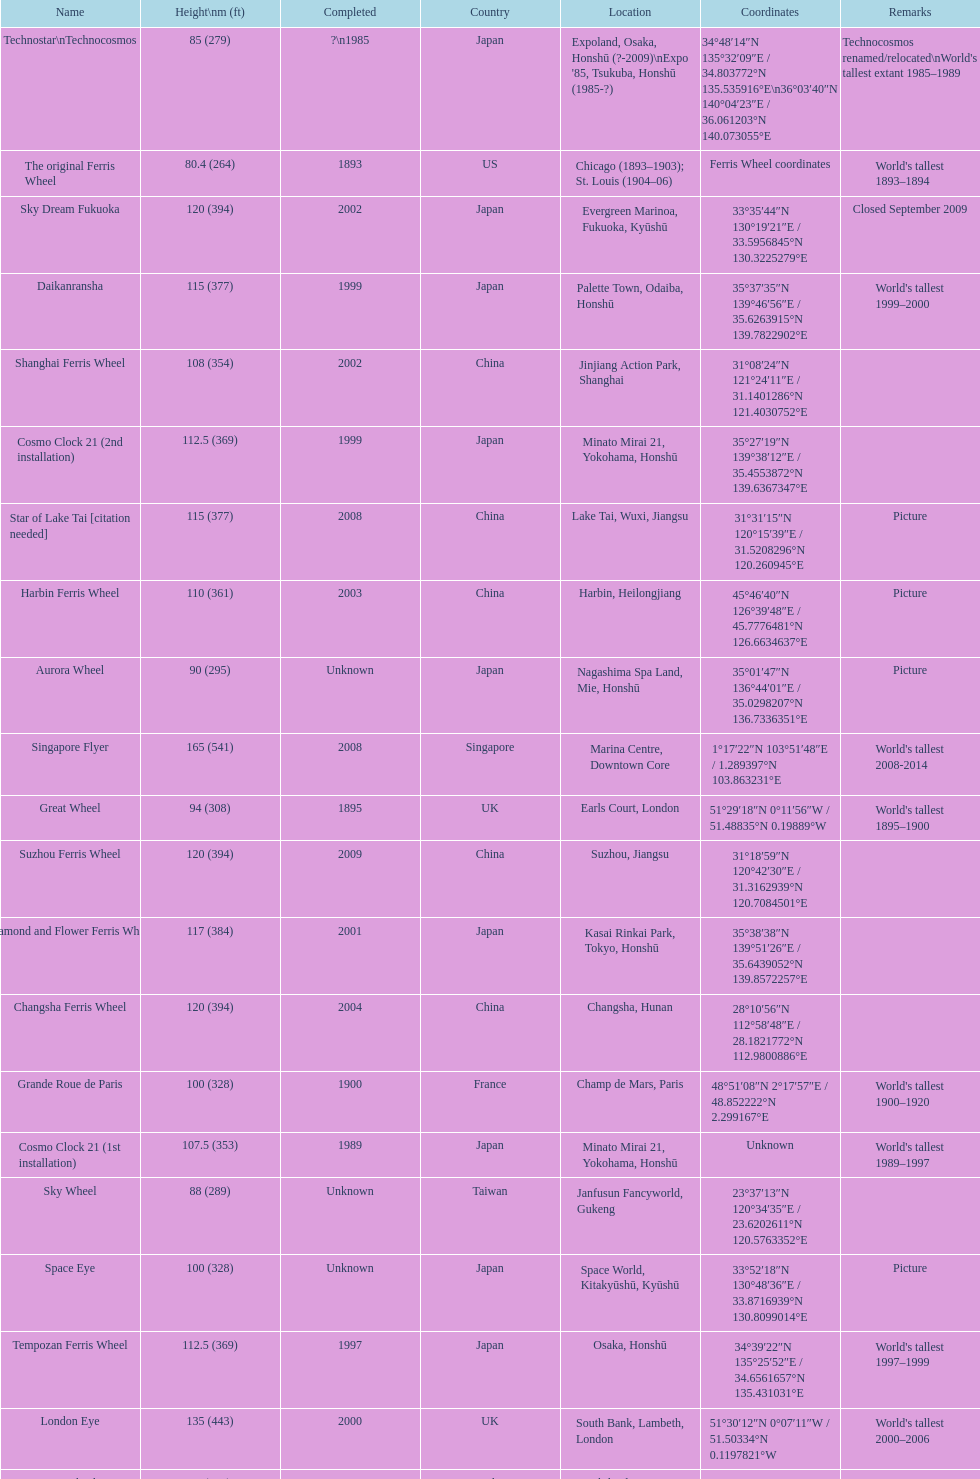Where was the original tallest roller coster built? Chicago. Would you be able to parse every entry in this table? {'header': ['Name', 'Height\\nm (ft)', 'Completed', 'Country', 'Location', 'Coordinates', 'Remarks'], 'rows': [['Technostar\\nTechnocosmos', '85 (279)', '?\\n1985', 'Japan', "Expoland, Osaka, Honshū (?-2009)\\nExpo '85, Tsukuba, Honshū (1985-?)", '34°48′14″N 135°32′09″E\ufeff / \ufeff34.803772°N 135.535916°E\\n36°03′40″N 140°04′23″E\ufeff / \ufeff36.061203°N 140.073055°E', "Technocosmos renamed/relocated\\nWorld's tallest extant 1985–1989"], ['The original Ferris Wheel', '80.4 (264)', '1893', 'US', 'Chicago (1893–1903); St. Louis (1904–06)', 'Ferris Wheel coordinates', "World's tallest 1893–1894"], ['Sky Dream Fukuoka', '120 (394)', '2002', 'Japan', 'Evergreen Marinoa, Fukuoka, Kyūshū', '33°35′44″N 130°19′21″E\ufeff / \ufeff33.5956845°N 130.3225279°E', 'Closed September 2009'], ['Daikanransha', '115 (377)', '1999', 'Japan', 'Palette Town, Odaiba, Honshū', '35°37′35″N 139°46′56″E\ufeff / \ufeff35.6263915°N 139.7822902°E', "World's tallest 1999–2000"], ['Shanghai Ferris Wheel', '108 (354)', '2002', 'China', 'Jinjiang Action Park, Shanghai', '31°08′24″N 121°24′11″E\ufeff / \ufeff31.1401286°N 121.4030752°E', ''], ['Cosmo Clock 21 (2nd installation)', '112.5 (369)', '1999', 'Japan', 'Minato Mirai 21, Yokohama, Honshū', '35°27′19″N 139°38′12″E\ufeff / \ufeff35.4553872°N 139.6367347°E', ''], ['Star of Lake Tai\xa0[citation needed]', '115 (377)', '2008', 'China', 'Lake Tai, Wuxi, Jiangsu', '31°31′15″N 120°15′39″E\ufeff / \ufeff31.5208296°N 120.260945°E', 'Picture'], ['Harbin Ferris Wheel', '110 (361)', '2003', 'China', 'Harbin, Heilongjiang', '45°46′40″N 126°39′48″E\ufeff / \ufeff45.7776481°N 126.6634637°E', 'Picture'], ['Aurora Wheel', '90 (295)', 'Unknown', 'Japan', 'Nagashima Spa Land, Mie, Honshū', '35°01′47″N 136°44′01″E\ufeff / \ufeff35.0298207°N 136.7336351°E', 'Picture'], ['Singapore Flyer', '165 (541)', '2008', 'Singapore', 'Marina Centre, Downtown Core', '1°17′22″N 103°51′48″E\ufeff / \ufeff1.289397°N 103.863231°E', "World's tallest 2008-2014"], ['Great Wheel', '94 (308)', '1895', 'UK', 'Earls Court, London', '51°29′18″N 0°11′56″W\ufeff / \ufeff51.48835°N 0.19889°W', "World's tallest 1895–1900"], ['Suzhou Ferris Wheel', '120 (394)', '2009', 'China', 'Suzhou, Jiangsu', '31°18′59″N 120°42′30″E\ufeff / \ufeff31.3162939°N 120.7084501°E', ''], ['Diamond\xa0and\xa0Flower\xa0Ferris\xa0Wheel', '117 (384)', '2001', 'Japan', 'Kasai Rinkai Park, Tokyo, Honshū', '35°38′38″N 139°51′26″E\ufeff / \ufeff35.6439052°N 139.8572257°E', ''], ['Changsha Ferris Wheel', '120 (394)', '2004', 'China', 'Changsha, Hunan', '28°10′56″N 112°58′48″E\ufeff / \ufeff28.1821772°N 112.9800886°E', ''], ['Grande Roue de Paris', '100 (328)', '1900', 'France', 'Champ de Mars, Paris', '48°51′08″N 2°17′57″E\ufeff / \ufeff48.852222°N 2.299167°E', "World's tallest 1900–1920"], ['Cosmo Clock 21 (1st installation)', '107.5 (353)', '1989', 'Japan', 'Minato Mirai 21, Yokohama, Honshū', 'Unknown', "World's tallest 1989–1997"], ['Sky Wheel', '88 (289)', 'Unknown', 'Taiwan', 'Janfusun Fancyworld, Gukeng', '23°37′13″N 120°34′35″E\ufeff / \ufeff23.6202611°N 120.5763352°E', ''], ['Space Eye', '100 (328)', 'Unknown', 'Japan', 'Space World, Kitakyūshū, Kyūshū', '33°52′18″N 130°48′36″E\ufeff / \ufeff33.8716939°N 130.8099014°E', 'Picture'], ['Tempozan Ferris Wheel', '112.5 (369)', '1997', 'Japan', 'Osaka, Honshū', '34°39′22″N 135°25′52″E\ufeff / \ufeff34.6561657°N 135.431031°E', "World's tallest 1997–1999"], ['London Eye', '135 (443)', '2000', 'UK', 'South Bank, Lambeth, London', '51°30′12″N 0°07′11″W\ufeff / \ufeff51.50334°N 0.1197821°W', "World's tallest 2000–2006"], ['Eurowheel', '90 (295)', '1999', 'Italy', 'Mirabilandia, Ravenna', '44°20′21″N 12°15′44″E\ufeff / \ufeff44.3392161°N 12.2622228°E', ''], ['Melbourne Star', '120 (394)', '2008', 'Australia', 'Docklands, Melbourne', '37°48′40″S 144°56′13″E\ufeff / \ufeff37.8110723°S 144.9368763°E', ''], ['Zhengzhou Ferris Wheel', '120 (394)', '2003', 'China', 'Century Amusement Park, Henan', '34°43′58″N 113°43′07″E\ufeff / \ufeff34.732871°N 113.718739°E', ''], ['Tianjin Eye', '120 (394)', '2008', 'China', 'Yongle Bridge, Tianjin', '39°09′12″N 117°10′49″E\ufeff / \ufeff39.1533636°N 117.1802616°E', ''], ['Star of Nanchang', '160 (525)', '2006', 'China', 'Nanchang, Jiangxi', '28°39′34″N 115°50′44″E\ufeff / \ufeff28.659332°N 115.845568°E', "World's tallest 2006–2008"], ['High Roller', '168 (551)', '2014', 'US', 'Las Vegas, Nevada', '36°07′03″N 115°10′05″W\ufeff / \ufeff36.117402°N 115.168127°W', "World's tallest since 2014"]]} 